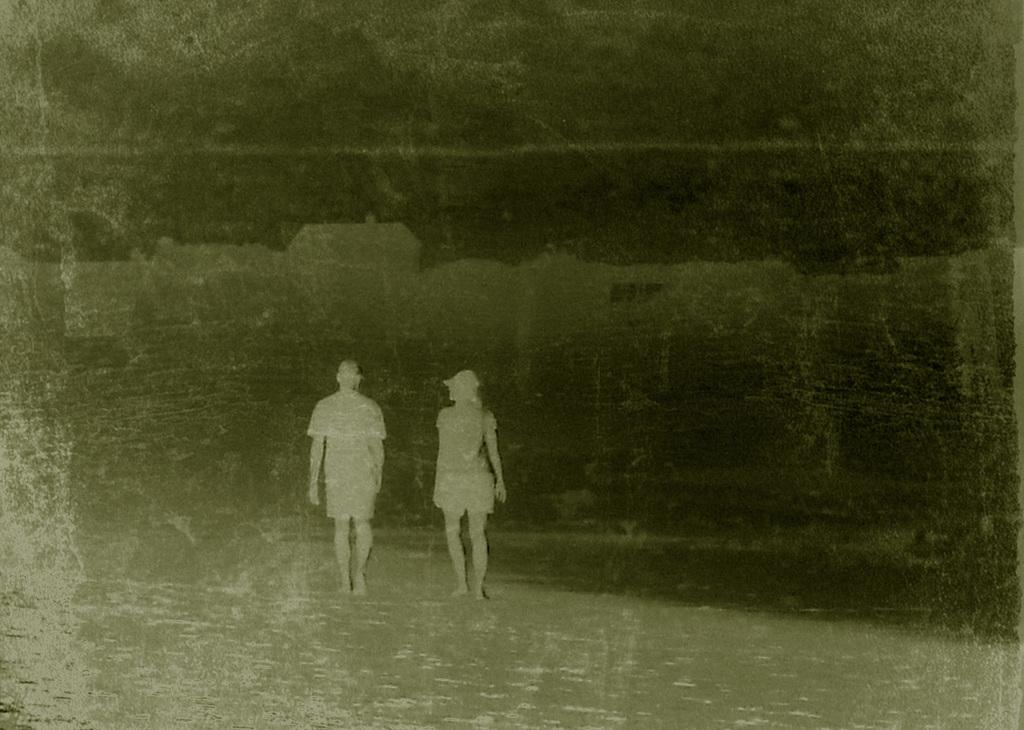What is the color scheme of the photo? The photo is black and white. What can be seen in the photo? There are people in the photo. What type of discovery was made on the bridge in the photo? There is no bridge or discovery present in the photo; it only features people in a black and white setting. 